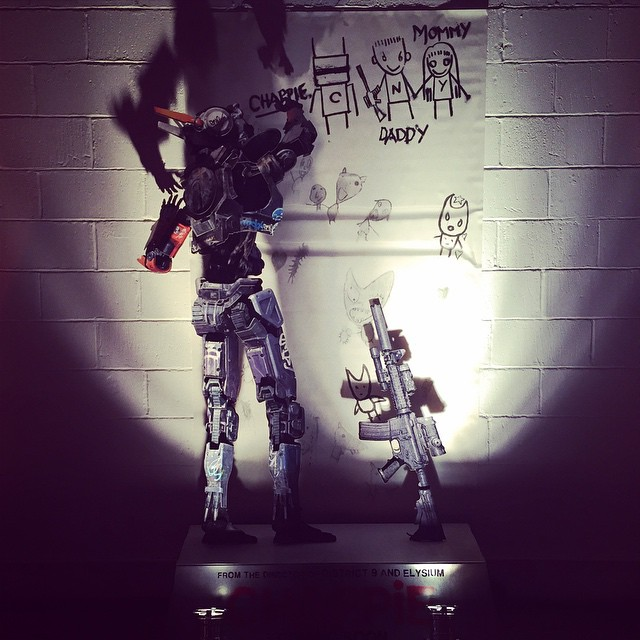Create a whimsical and imaginative question about the image. What if the robot in the image is actually an artist, and every night it comes to life to magically paint and draw on the walls, bringing the children's fantasies to life? What stories and adventures might emerge from its nocturnal artistic endeavors? The robot artist, known as 'Brush-Bot,' awakens each night when the household is asleep. It draws from its memory bank containing every child’s dream and idea ever shared with it. One night, Brush-Bot brings to life a magical forest where the animals talk and the trees whisper ancient secrets. The children wake up to find that their living room has turned into a portal to this enchanted world, igniting their imaginations and setting them off on whimsical adventures of discovery and friendship with the forest creatures. Each night brings a new story and setting, transforming ordinary walls into gateways to fantastical realms. 